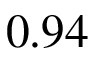Convert formula to latex. <formula><loc_0><loc_0><loc_500><loc_500>0 . 9 4</formula> 